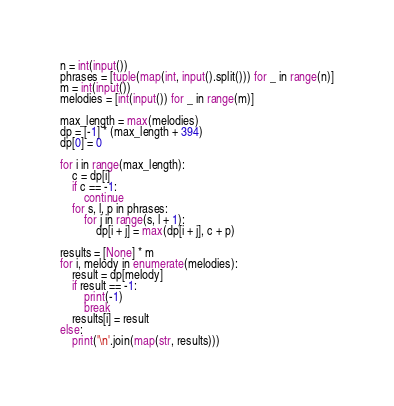Convert code to text. <code><loc_0><loc_0><loc_500><loc_500><_Python_>n = int(input())
phrases = [tuple(map(int, input().split())) for _ in range(n)]
m = int(input())
melodies = [int(input()) for _ in range(m)]

max_length = max(melodies)
dp = [-1] * (max_length + 394)
dp[0] = 0

for i in range(max_length):
    c = dp[i]
    if c == -1:
        continue
    for s, l, p in phrases:
        for j in range(s, l + 1):
            dp[i + j] = max(dp[i + j], c + p)

results = [None] * m
for i, melody in enumerate(melodies):
    result = dp[melody]
    if result == -1:
        print(-1)
        break
    results[i] = result
else:
    print('\n'.join(map(str, results)))</code> 